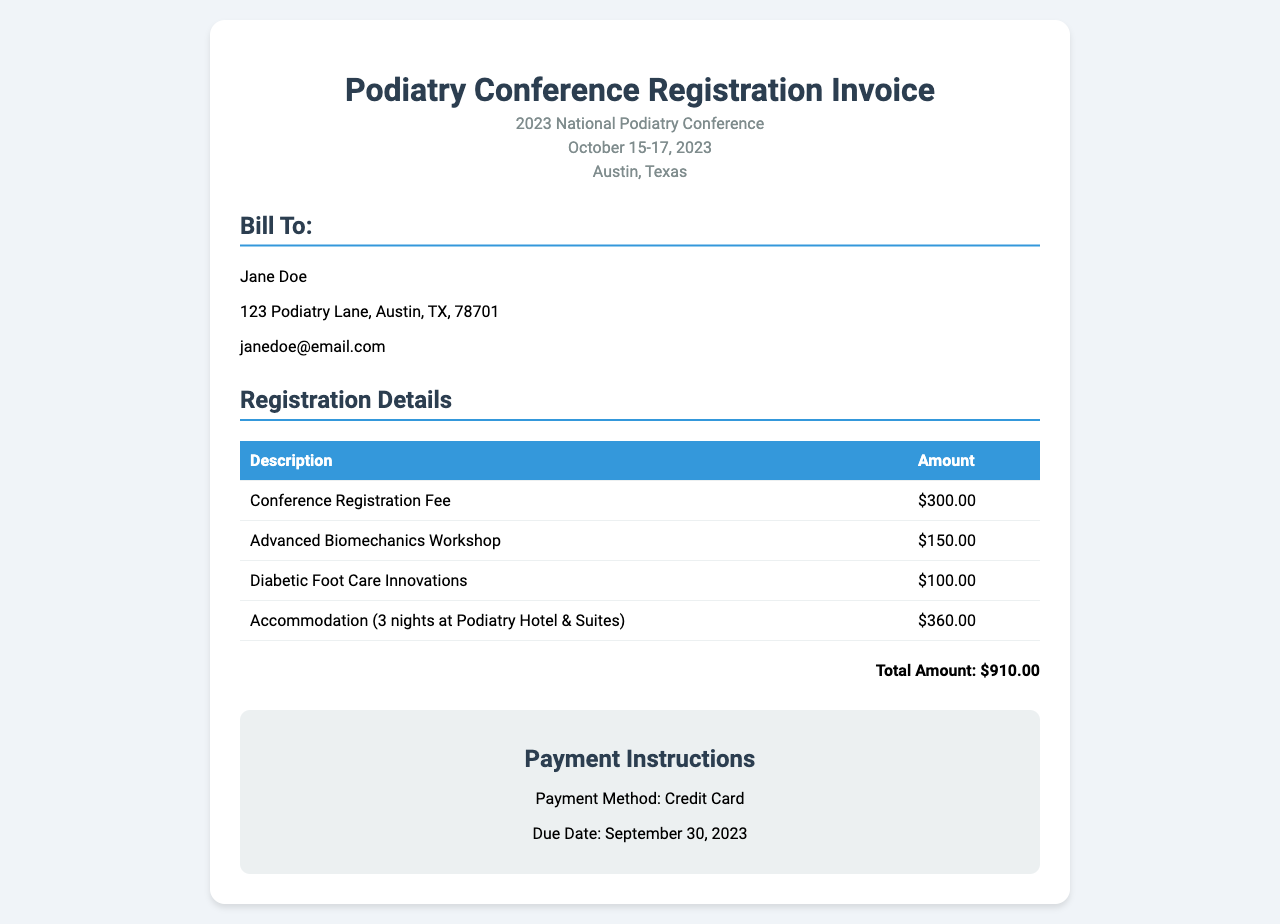What is the total amount due? The total amount due is stated clearly in the document under the total section.
Answer: $910.00 What is the registration fee for the conference? The registration fee is listed as one of the chargeable items in the invoice.
Answer: $300.00 What is the date of the conference? The date of the conference can be found in the header section of the invoice.
Answer: October 15-17, 2023 How many nights of accommodation are included? The accommodation cost mentions the number of nights directly in its description.
Answer: 3 nights What payment method is accepted? The payment method is explicitly mentioned in the payment instructions section.
Answer: Credit Card What is the name of the hotel for accommodation? The accommodation description specifies the hotel name where the stay occurs.
Answer: Podiatry Hotel & Suites What is the due date for payment? The due date for payment is stated in the payment instructions part of the document.
Answer: September 30, 2023 How much is the fee for the Advanced Biomechanics Workshop? The fee for this specific workshop is listed in the registration details table.
Answer: $150.00 